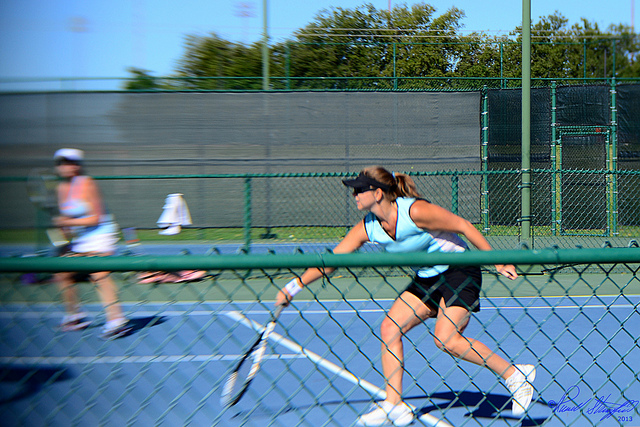What surface are they playing on?
A. clay
B. indoor hard
C. outdoor hard
D. grass
Answer with the option's letter from the given choices directly. C 